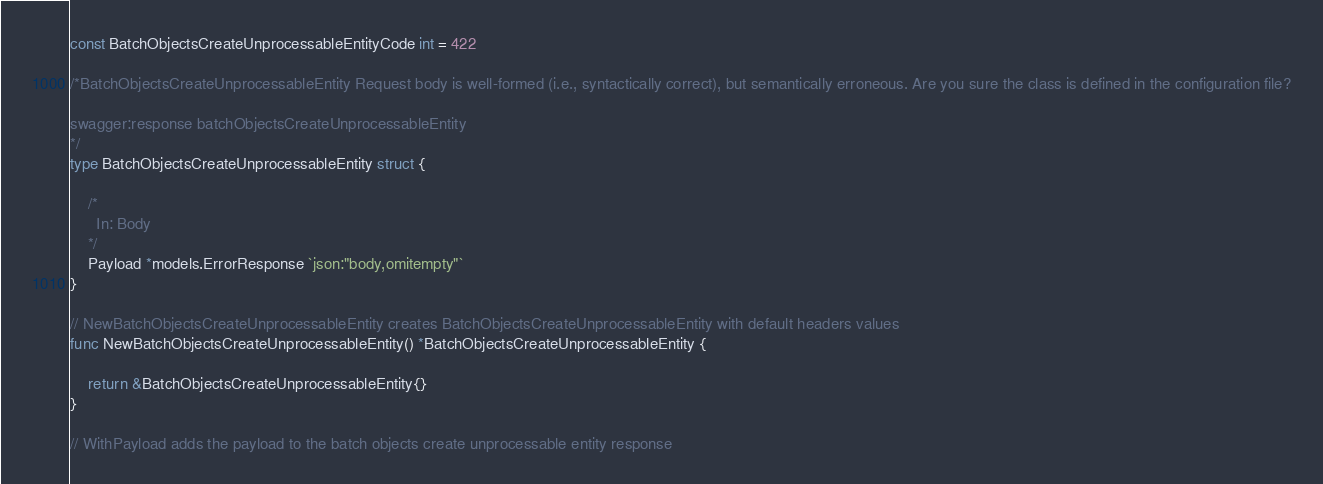<code> <loc_0><loc_0><loc_500><loc_500><_Go_>const BatchObjectsCreateUnprocessableEntityCode int = 422

/*BatchObjectsCreateUnprocessableEntity Request body is well-formed (i.e., syntactically correct), but semantically erroneous. Are you sure the class is defined in the configuration file?

swagger:response batchObjectsCreateUnprocessableEntity
*/
type BatchObjectsCreateUnprocessableEntity struct {

	/*
	  In: Body
	*/
	Payload *models.ErrorResponse `json:"body,omitempty"`
}

// NewBatchObjectsCreateUnprocessableEntity creates BatchObjectsCreateUnprocessableEntity with default headers values
func NewBatchObjectsCreateUnprocessableEntity() *BatchObjectsCreateUnprocessableEntity {

	return &BatchObjectsCreateUnprocessableEntity{}
}

// WithPayload adds the payload to the batch objects create unprocessable entity response</code> 